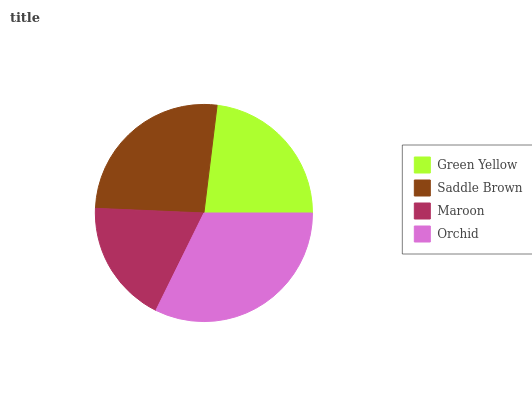Is Maroon the minimum?
Answer yes or no. Yes. Is Orchid the maximum?
Answer yes or no. Yes. Is Saddle Brown the minimum?
Answer yes or no. No. Is Saddle Brown the maximum?
Answer yes or no. No. Is Saddle Brown greater than Green Yellow?
Answer yes or no. Yes. Is Green Yellow less than Saddle Brown?
Answer yes or no. Yes. Is Green Yellow greater than Saddle Brown?
Answer yes or no. No. Is Saddle Brown less than Green Yellow?
Answer yes or no. No. Is Saddle Brown the high median?
Answer yes or no. Yes. Is Green Yellow the low median?
Answer yes or no. Yes. Is Maroon the high median?
Answer yes or no. No. Is Maroon the low median?
Answer yes or no. No. 